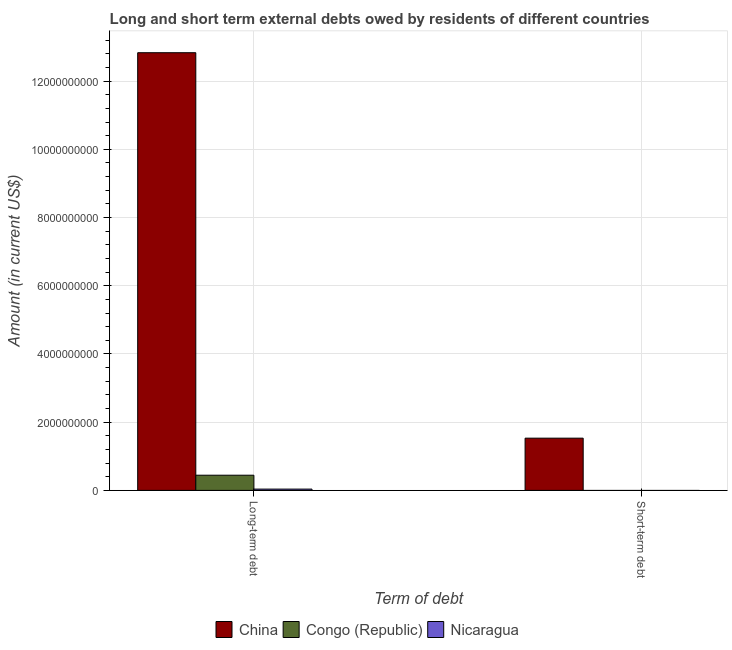How many different coloured bars are there?
Provide a short and direct response. 3. What is the label of the 2nd group of bars from the left?
Offer a very short reply. Short-term debt. What is the long-term debts owed by residents in Nicaragua?
Your answer should be very brief. 3.73e+07. Across all countries, what is the maximum long-term debts owed by residents?
Give a very brief answer. 1.28e+1. Across all countries, what is the minimum long-term debts owed by residents?
Provide a succinct answer. 3.73e+07. What is the total long-term debts owed by residents in the graph?
Give a very brief answer. 1.33e+1. What is the difference between the long-term debts owed by residents in Congo (Republic) and that in Nicaragua?
Your answer should be compact. 4.07e+08. What is the difference between the short-term debts owed by residents in Congo (Republic) and the long-term debts owed by residents in China?
Offer a very short reply. -1.28e+1. What is the average long-term debts owed by residents per country?
Keep it short and to the point. 4.44e+09. What is the difference between the long-term debts owed by residents and short-term debts owed by residents in China?
Make the answer very short. 1.13e+1. What is the ratio of the long-term debts owed by residents in Nicaragua to that in China?
Your answer should be compact. 0. How many bars are there?
Make the answer very short. 4. Are all the bars in the graph horizontal?
Give a very brief answer. No. How many countries are there in the graph?
Your response must be concise. 3. Are the values on the major ticks of Y-axis written in scientific E-notation?
Provide a short and direct response. No. Does the graph contain any zero values?
Your response must be concise. Yes. Where does the legend appear in the graph?
Your answer should be compact. Bottom center. What is the title of the graph?
Keep it short and to the point. Long and short term external debts owed by residents of different countries. Does "Bangladesh" appear as one of the legend labels in the graph?
Provide a succinct answer. No. What is the label or title of the X-axis?
Your answer should be compact. Term of debt. What is the Amount (in current US$) of China in Long-term debt?
Make the answer very short. 1.28e+1. What is the Amount (in current US$) of Congo (Republic) in Long-term debt?
Your answer should be very brief. 4.45e+08. What is the Amount (in current US$) of Nicaragua in Long-term debt?
Your response must be concise. 3.73e+07. What is the Amount (in current US$) of China in Short-term debt?
Offer a very short reply. 1.53e+09. What is the Amount (in current US$) of Congo (Republic) in Short-term debt?
Your response must be concise. 0. Across all Term of debt, what is the maximum Amount (in current US$) in China?
Your answer should be compact. 1.28e+1. Across all Term of debt, what is the maximum Amount (in current US$) of Congo (Republic)?
Make the answer very short. 4.45e+08. Across all Term of debt, what is the maximum Amount (in current US$) in Nicaragua?
Make the answer very short. 3.73e+07. Across all Term of debt, what is the minimum Amount (in current US$) of China?
Your response must be concise. 1.53e+09. Across all Term of debt, what is the minimum Amount (in current US$) in Congo (Republic)?
Make the answer very short. 0. What is the total Amount (in current US$) of China in the graph?
Your response must be concise. 1.44e+1. What is the total Amount (in current US$) in Congo (Republic) in the graph?
Offer a terse response. 4.45e+08. What is the total Amount (in current US$) in Nicaragua in the graph?
Your answer should be very brief. 3.73e+07. What is the difference between the Amount (in current US$) of China in Long-term debt and that in Short-term debt?
Keep it short and to the point. 1.13e+1. What is the average Amount (in current US$) in China per Term of debt?
Offer a very short reply. 7.18e+09. What is the average Amount (in current US$) in Congo (Republic) per Term of debt?
Make the answer very short. 2.22e+08. What is the average Amount (in current US$) in Nicaragua per Term of debt?
Provide a short and direct response. 1.87e+07. What is the difference between the Amount (in current US$) of China and Amount (in current US$) of Congo (Republic) in Long-term debt?
Make the answer very short. 1.24e+1. What is the difference between the Amount (in current US$) in China and Amount (in current US$) in Nicaragua in Long-term debt?
Your response must be concise. 1.28e+1. What is the difference between the Amount (in current US$) of Congo (Republic) and Amount (in current US$) of Nicaragua in Long-term debt?
Your answer should be very brief. 4.07e+08. What is the ratio of the Amount (in current US$) of China in Long-term debt to that in Short-term debt?
Keep it short and to the point. 8.38. What is the difference between the highest and the second highest Amount (in current US$) in China?
Ensure brevity in your answer.  1.13e+1. What is the difference between the highest and the lowest Amount (in current US$) in China?
Make the answer very short. 1.13e+1. What is the difference between the highest and the lowest Amount (in current US$) of Congo (Republic)?
Offer a very short reply. 4.45e+08. What is the difference between the highest and the lowest Amount (in current US$) in Nicaragua?
Offer a terse response. 3.73e+07. 